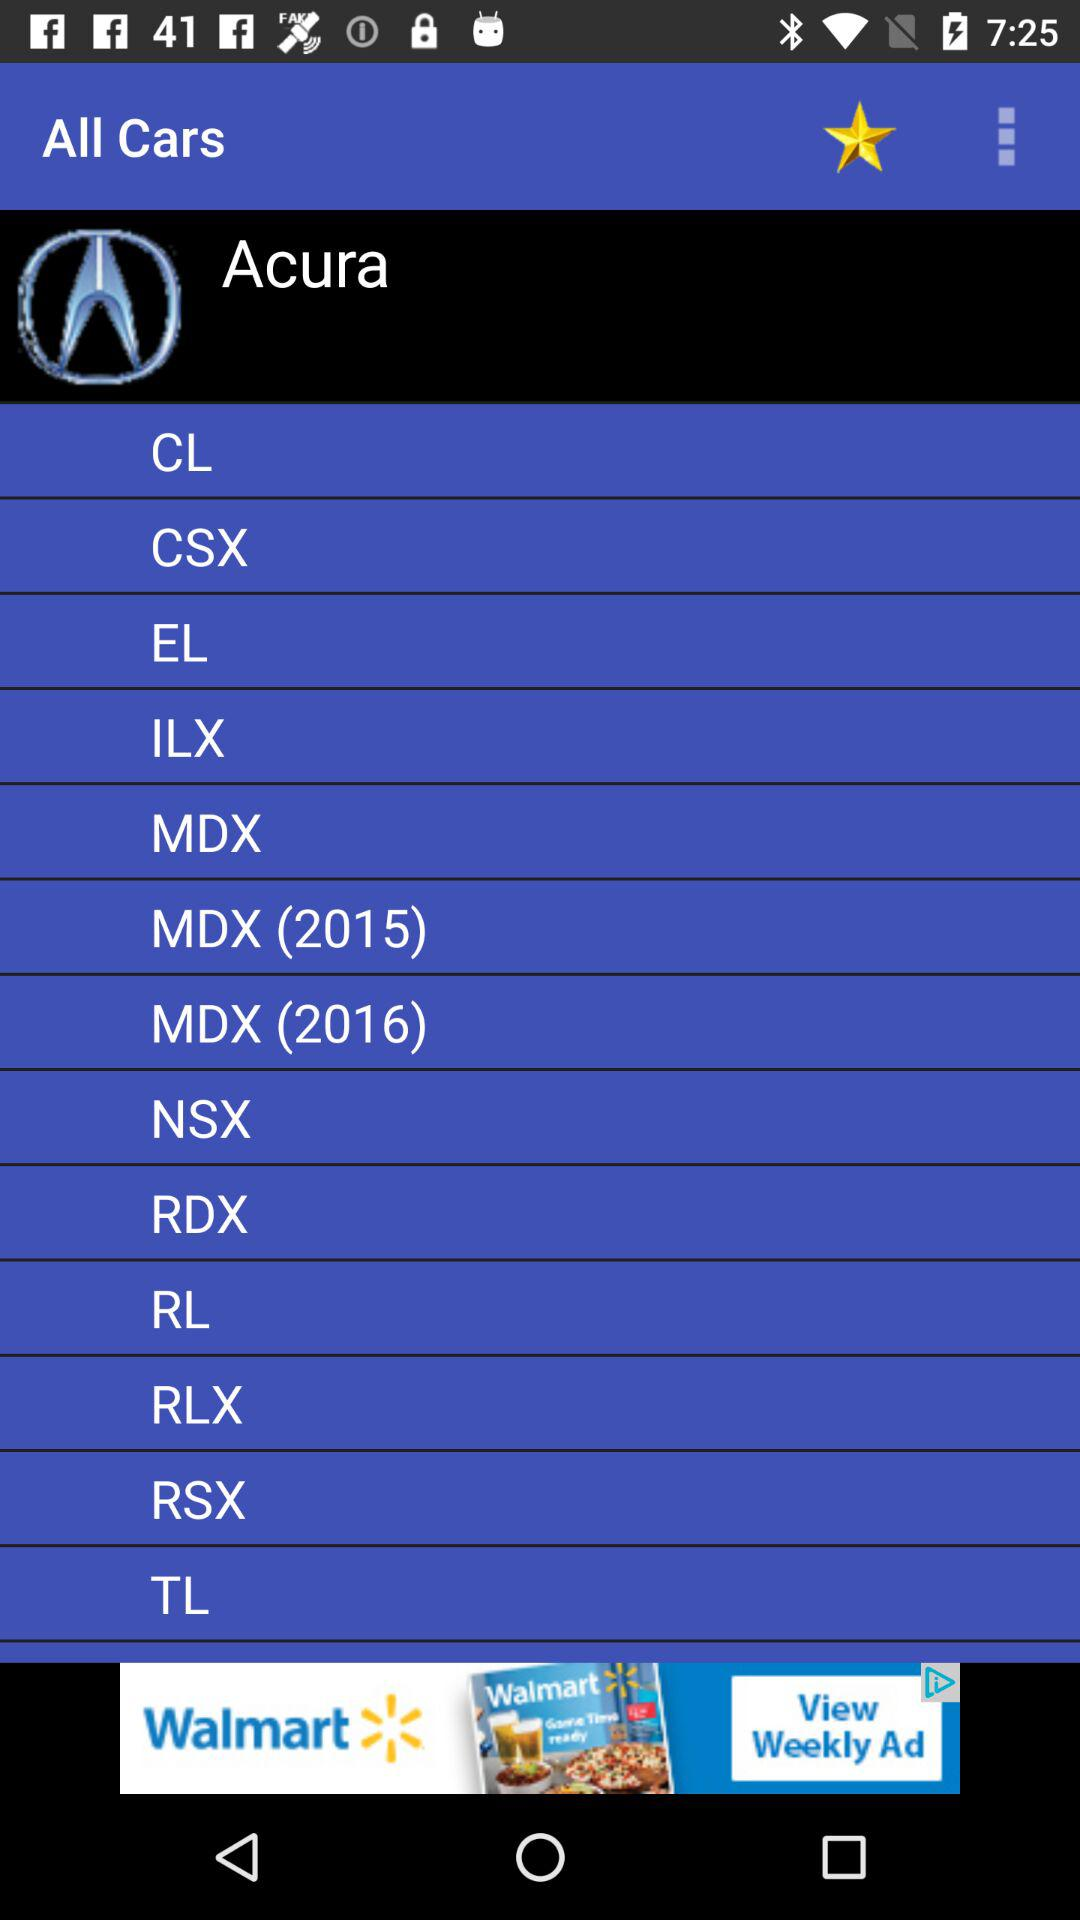What is the app name? The app name is "All Cars". 